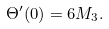Convert formula to latex. <formula><loc_0><loc_0><loc_500><loc_500>\Theta ^ { \prime } ( 0 ) = 6 M _ { 3 } .</formula> 